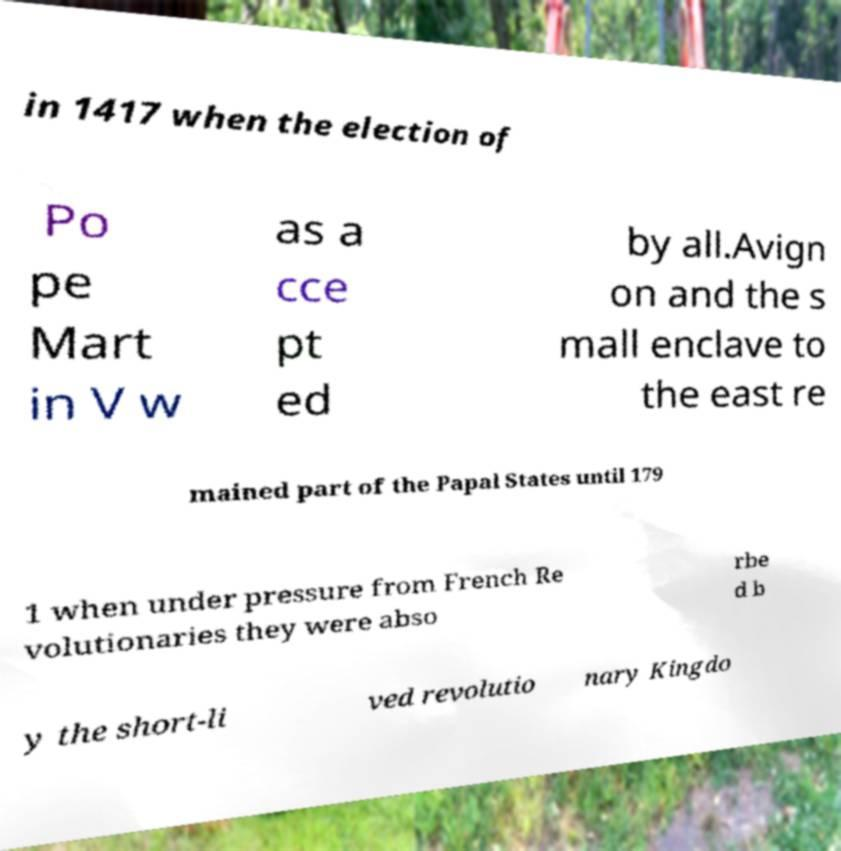There's text embedded in this image that I need extracted. Can you transcribe it verbatim? in 1417 when the election of Po pe Mart in V w as a cce pt ed by all.Avign on and the s mall enclave to the east re mained part of the Papal States until 179 1 when under pressure from French Re volutionaries they were abso rbe d b y the short-li ved revolutio nary Kingdo 